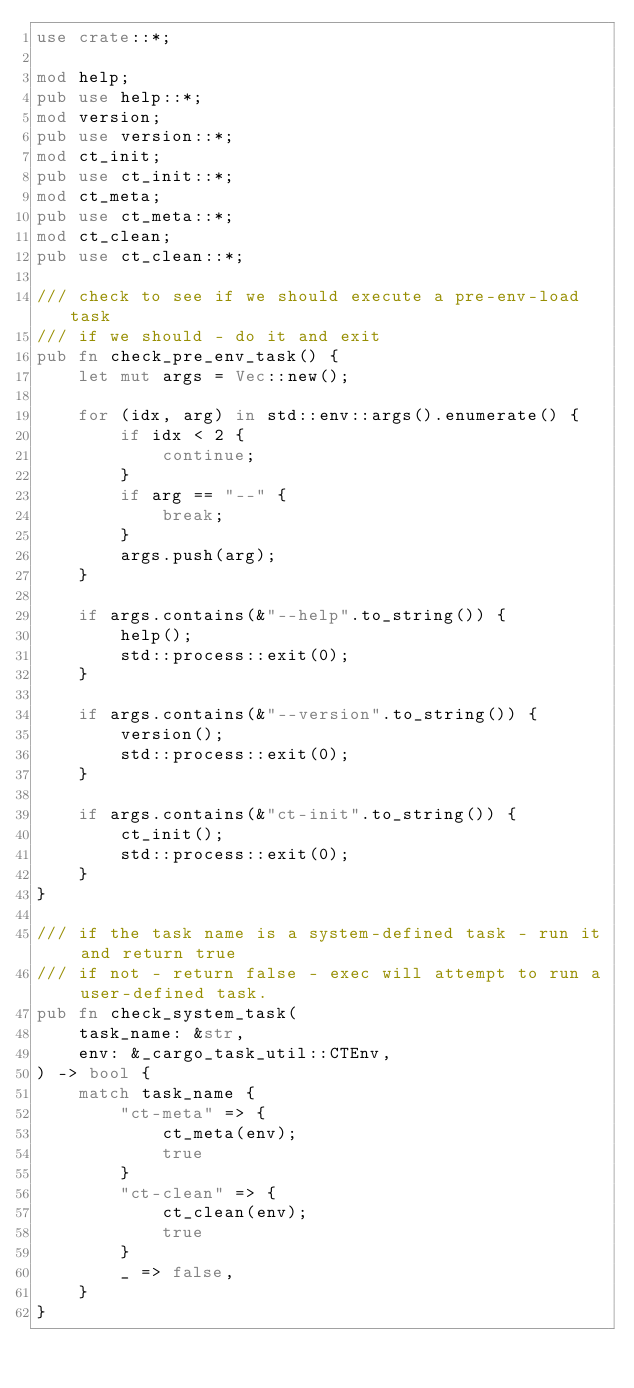<code> <loc_0><loc_0><loc_500><loc_500><_Rust_>use crate::*;

mod help;
pub use help::*;
mod version;
pub use version::*;
mod ct_init;
pub use ct_init::*;
mod ct_meta;
pub use ct_meta::*;
mod ct_clean;
pub use ct_clean::*;

/// check to see if we should execute a pre-env-load task
/// if we should - do it and exit
pub fn check_pre_env_task() {
    let mut args = Vec::new();

    for (idx, arg) in std::env::args().enumerate() {
        if idx < 2 {
            continue;
        }
        if arg == "--" {
            break;
        }
        args.push(arg);
    }

    if args.contains(&"--help".to_string()) {
        help();
        std::process::exit(0);
    }

    if args.contains(&"--version".to_string()) {
        version();
        std::process::exit(0);
    }

    if args.contains(&"ct-init".to_string()) {
        ct_init();
        std::process::exit(0);
    }
}

/// if the task name is a system-defined task - run it and return true
/// if not - return false - exec will attempt to run a user-defined task.
pub fn check_system_task(
    task_name: &str,
    env: &_cargo_task_util::CTEnv,
) -> bool {
    match task_name {
        "ct-meta" => {
            ct_meta(env);
            true
        }
        "ct-clean" => {
            ct_clean(env);
            true
        }
        _ => false,
    }
}
</code> 